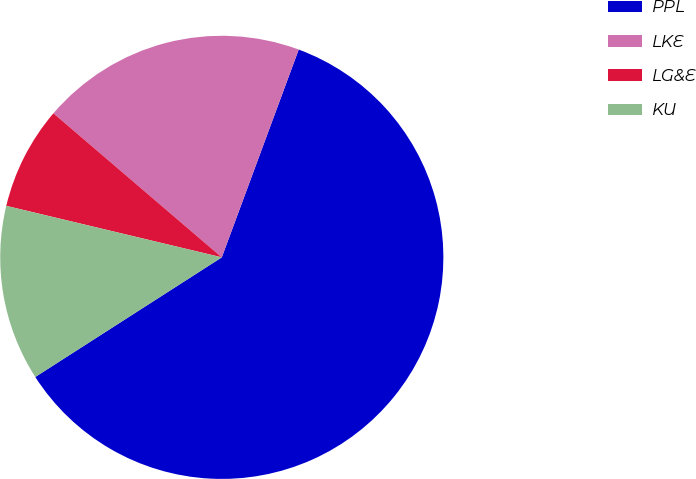Convert chart. <chart><loc_0><loc_0><loc_500><loc_500><pie_chart><fcel>PPL<fcel>LKE<fcel>LG&E<fcel>KU<nl><fcel>60.28%<fcel>19.38%<fcel>7.53%<fcel>12.81%<nl></chart> 